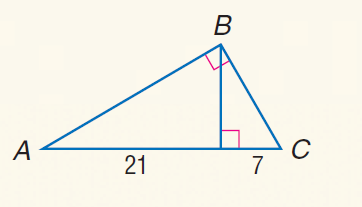Question: Find the measure of the altitude drawn to the hypotenuse.
Choices:
A. \sqrt { 7 }
B. 3
C. 7
D. 7 \sqrt { 3 }
Answer with the letter. Answer: D 